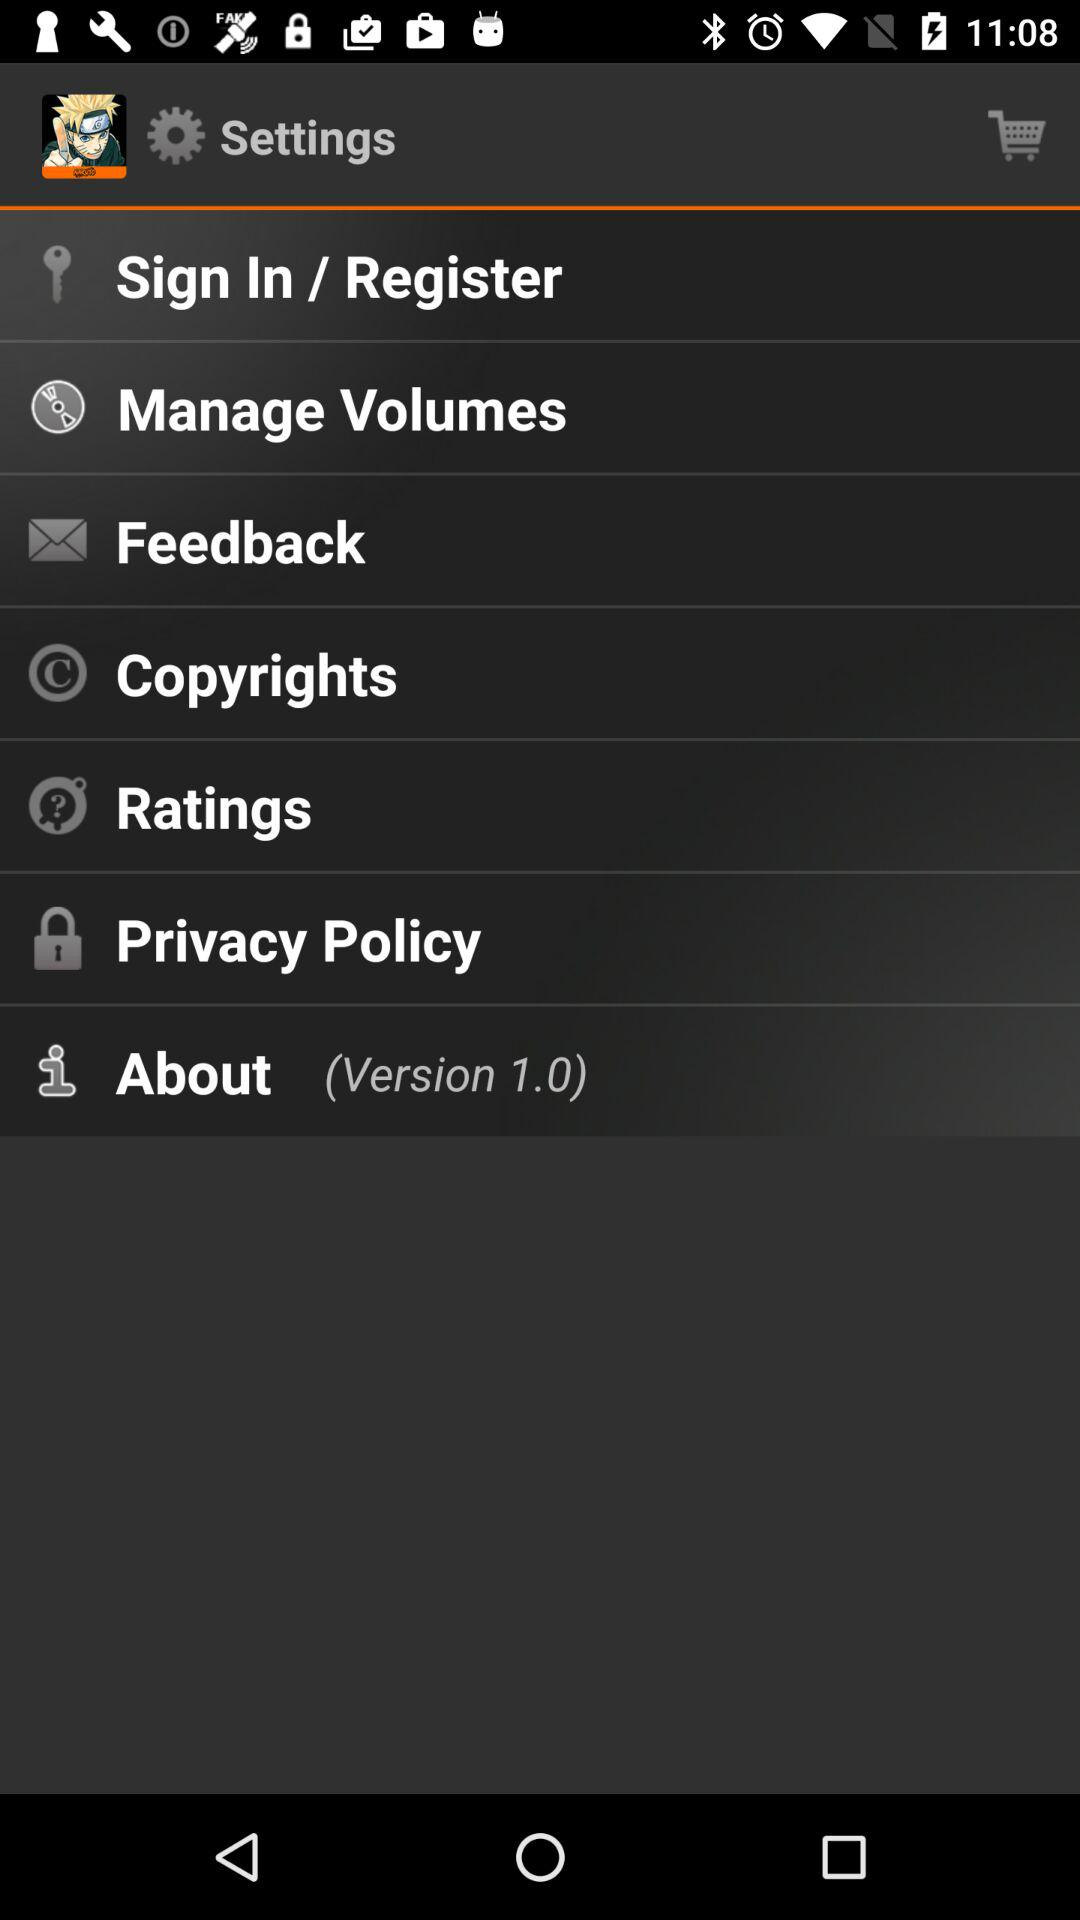When was the application copyrighted?
When the provided information is insufficient, respond with <no answer>. <no answer> 